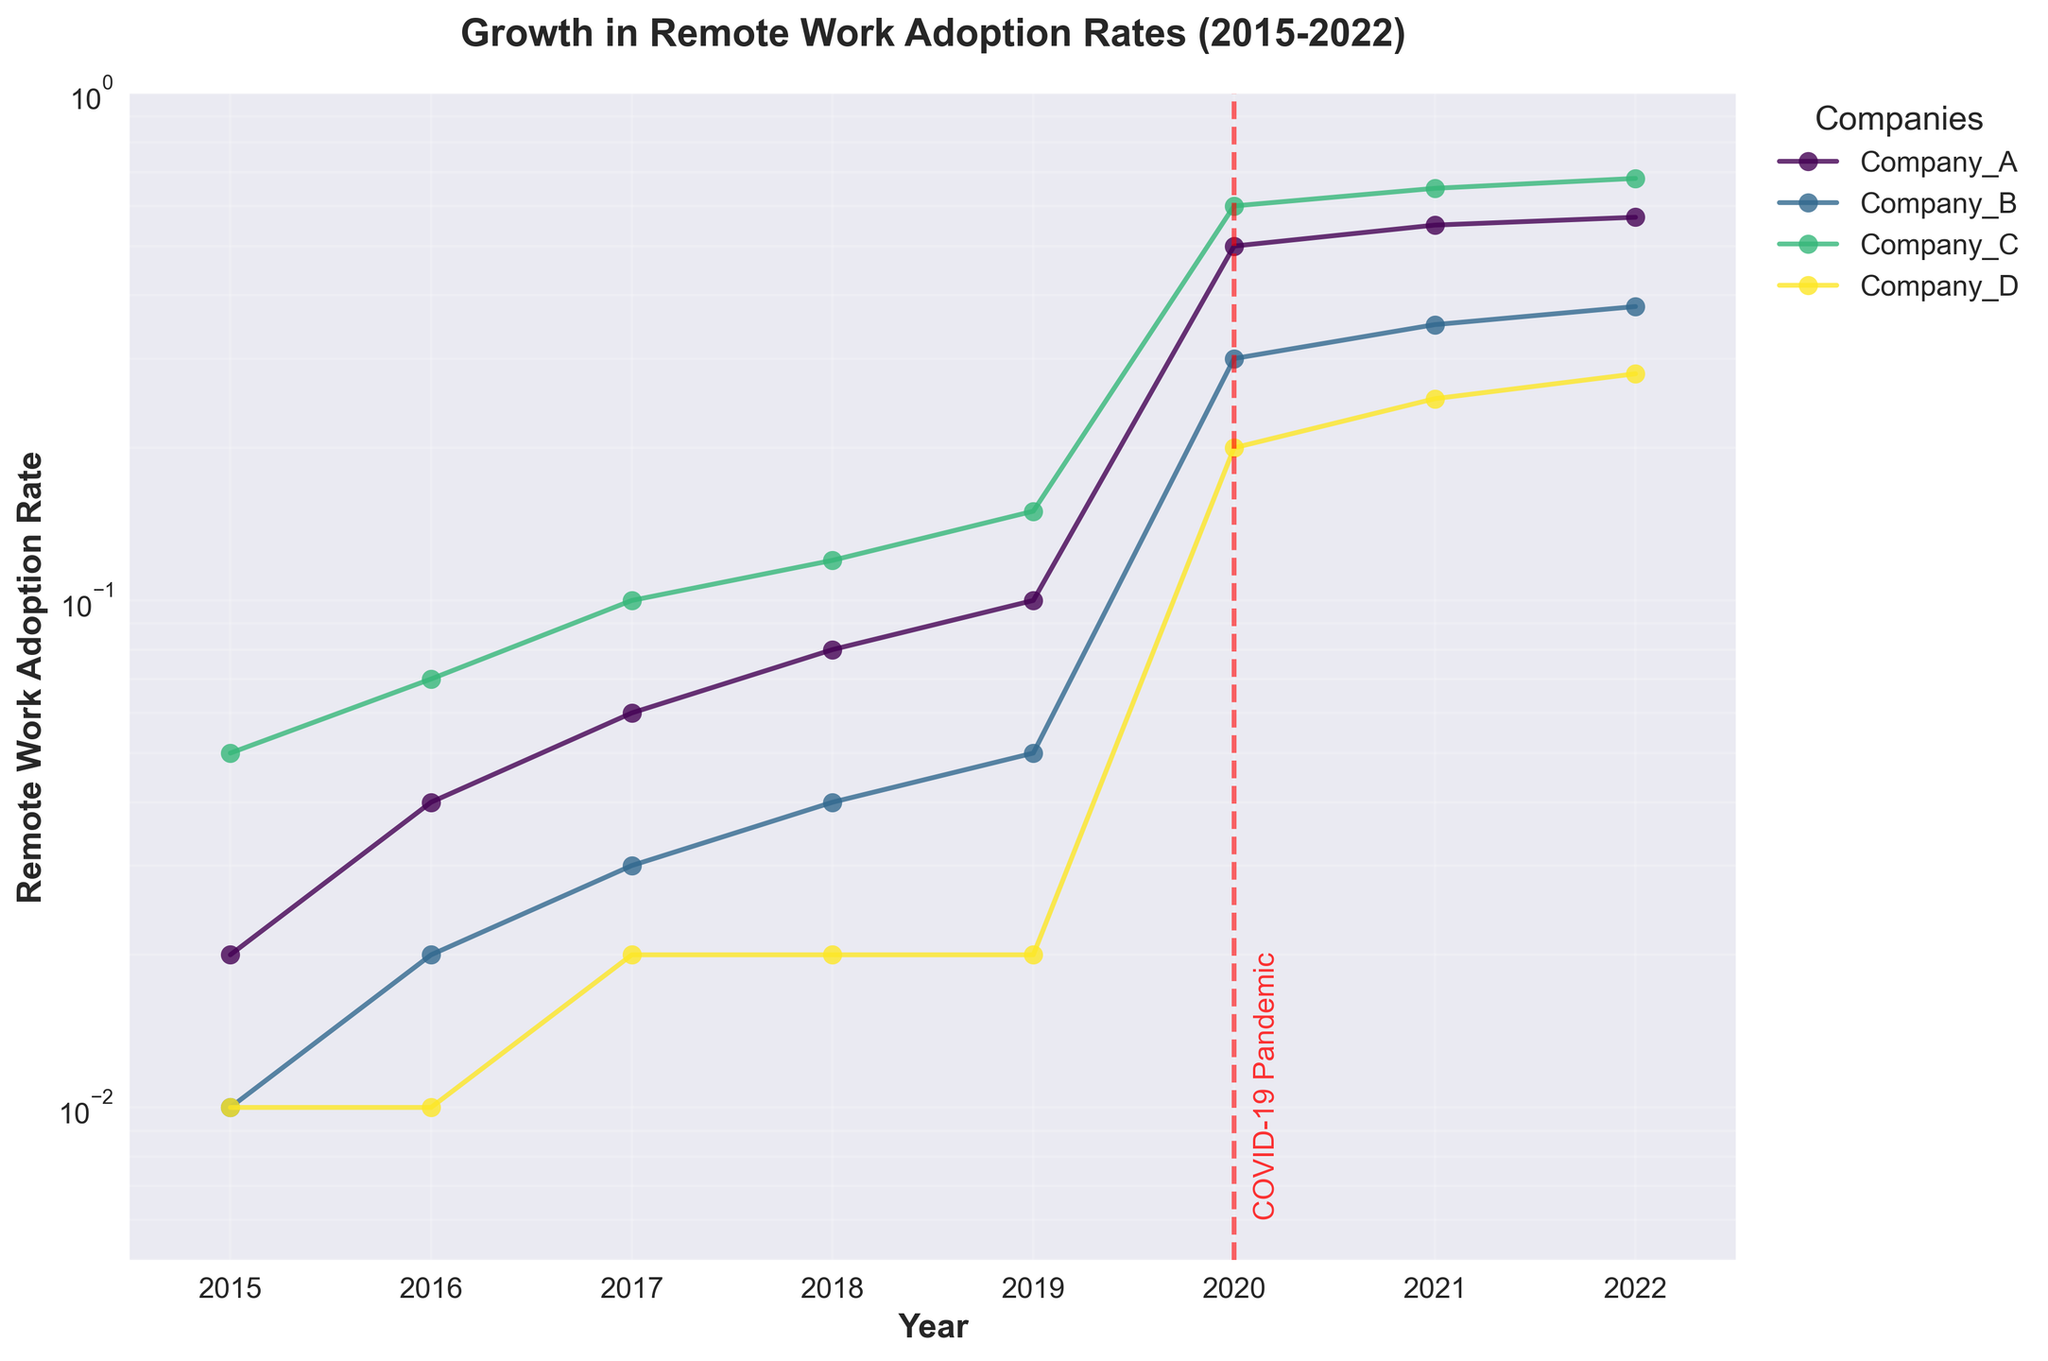What is the title of the figure? The title is located at the top of the figure, clearly stating what the plot shows.
Answer: Growth in Remote Work Adoption Rates (2015-2022) What is marked by the vertical red dashed line on the figure? The vertical red dashed line is annotated with "COVID-19 Pandemic", indicating the year 2020 marks the global event.
Answer: COVID-19 Pandemic Which company had the highest remote work adoption rate in 2022? By examining the value at 2022 for each company's plot, Company C has the highest adoption rate.
Answer: Company C Did any company have a remote work adoption rate of 0.01 in 2015? Checking the values at 2015, Company B and Company D had remote work adoption rates of 0.01.
Answer: Company B and Company D How did the remote work adoption rate of Company A change between 2018 and 2020? At 2018, the rate for Company A was 0.08, and it jumped to 0.50 in 2020. Hence, the difference is 0.50 - 0.08 = 0.42.
Answer: Increased by 0.42 Which company experienced the greatest increase in remote work adoption rate from 2019 to 2020? Calculating the differences between 2019 and 2020 for each company, Company C increased the most from 0.15 to 0.60 (0.45 increase).
Answer: Company C How does the trend in remote work adoption rates differ before and after 2020 across all companies? Before 2020, the growth rates were gradual and small. After 2020, all companies saw a significant spike, marking a sharp increase.
Answer: Small growth before 2020, sharp spike after 2020 Is the remote work adoption rate in 2022 higher than 2018 for all companies? Comparing values for each company, all have higher rates in 2022 than in 2018.
Answer: Yes What is the approximate remote work adoption rate of Company B in 2017? Checking the value for Company B at 2017, it's approximately 0.03.
Answer: 0.03 Which company's remote work adoption rate showed the least change between 2015 and 2019? Observing the values, Company D's rate remained the most constant, only slightly increasing from 0.01 to 0.02.
Answer: Company D 